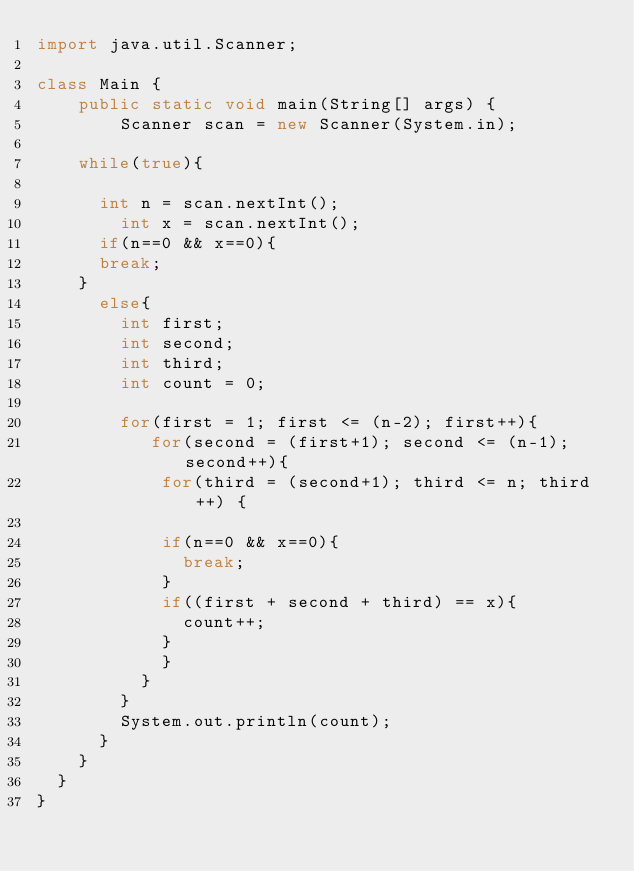Convert code to text. <code><loc_0><loc_0><loc_500><loc_500><_Java_>import java.util.Scanner;

class Main {
    public static void main(String[] args) {
        Scanner scan = new Scanner(System.in);

    while(true){ 
    	
    	int n = scan.nextInt();
        int x = scan.nextInt();
    	if(n==0 && x==0){
	 		break;
	 	}
    	else{
        int first;
        int second;
        int third;
        int count = 0;

        for(first = 1; first <= (n-2); first++){
        	 for(second = (first+1); second <= (n-1); second++){
        	 	for(third = (second+1); third <= n; third++) {
      
        	 	if(n==0 && x==0){
        	 		break;
        	 	}
        		if((first + second + third) == x){
        			count++;
        		}
        		}
        	}
        }
        System.out.println(count);
    	}
    }
 	}
}</code> 